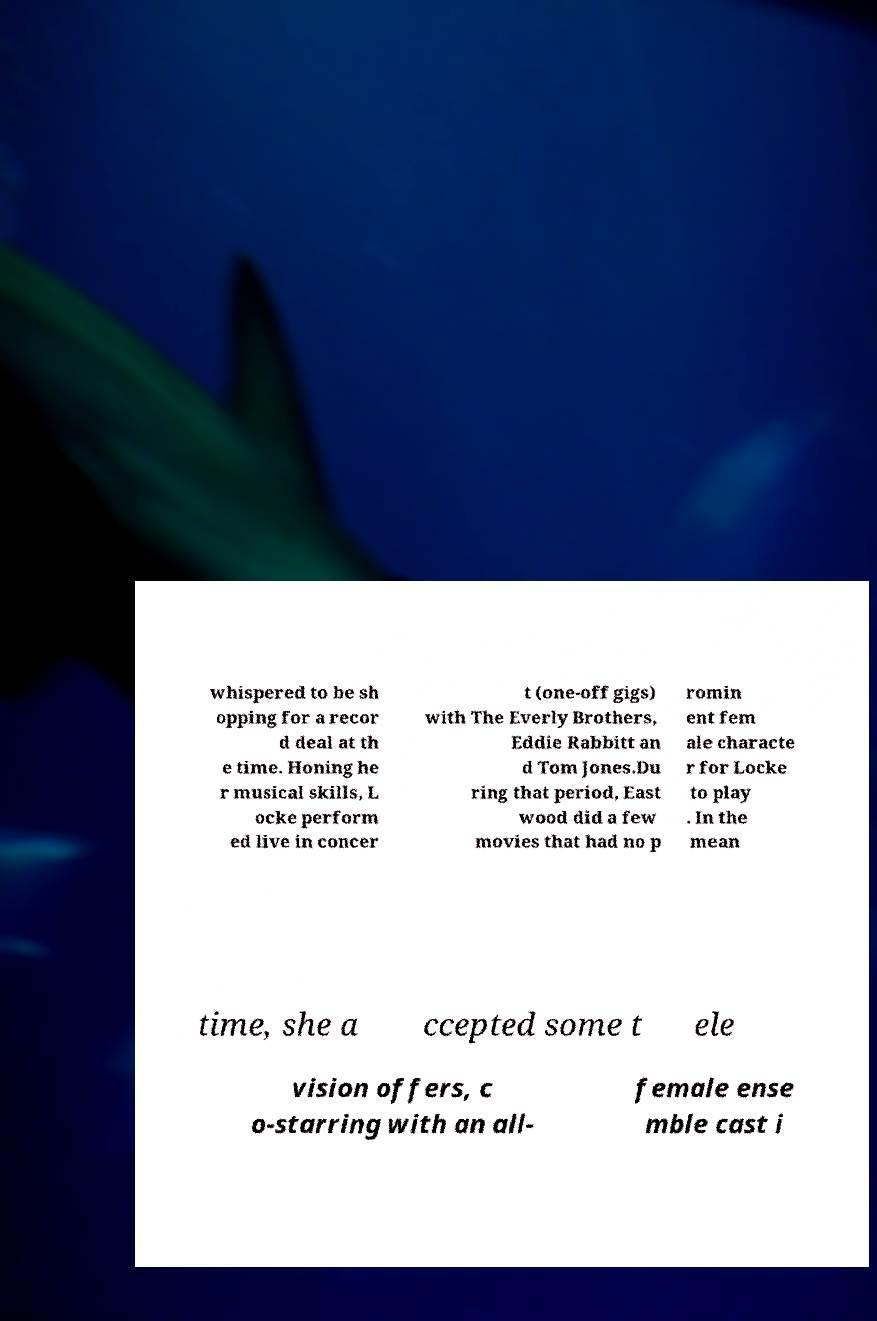What messages or text are displayed in this image? I need them in a readable, typed format. whispered to be sh opping for a recor d deal at th e time. Honing he r musical skills, L ocke perform ed live in concer t (one-off gigs) with The Everly Brothers, Eddie Rabbitt an d Tom Jones.Du ring that period, East wood did a few movies that had no p romin ent fem ale characte r for Locke to play . In the mean time, she a ccepted some t ele vision offers, c o-starring with an all- female ense mble cast i 